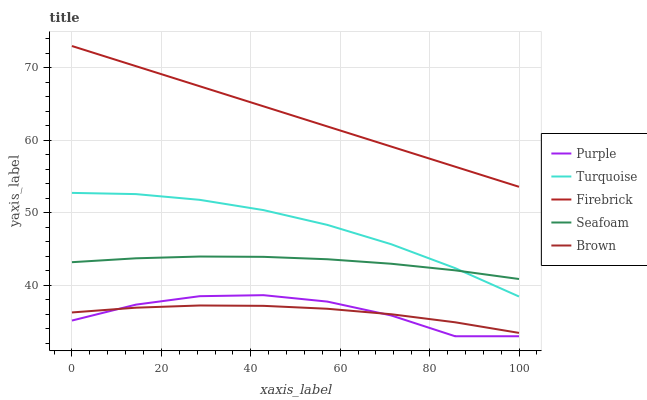Does Brown have the minimum area under the curve?
Answer yes or no. Yes. Does Firebrick have the maximum area under the curve?
Answer yes or no. Yes. Does Turquoise have the minimum area under the curve?
Answer yes or no. No. Does Turquoise have the maximum area under the curve?
Answer yes or no. No. Is Firebrick the smoothest?
Answer yes or no. Yes. Is Purple the roughest?
Answer yes or no. Yes. Is Brown the smoothest?
Answer yes or no. No. Is Brown the roughest?
Answer yes or no. No. Does Purple have the lowest value?
Answer yes or no. Yes. Does Brown have the lowest value?
Answer yes or no. No. Does Firebrick have the highest value?
Answer yes or no. Yes. Does Turquoise have the highest value?
Answer yes or no. No. Is Seafoam less than Firebrick?
Answer yes or no. Yes. Is Firebrick greater than Purple?
Answer yes or no. Yes. Does Brown intersect Purple?
Answer yes or no. Yes. Is Brown less than Purple?
Answer yes or no. No. Is Brown greater than Purple?
Answer yes or no. No. Does Seafoam intersect Firebrick?
Answer yes or no. No. 